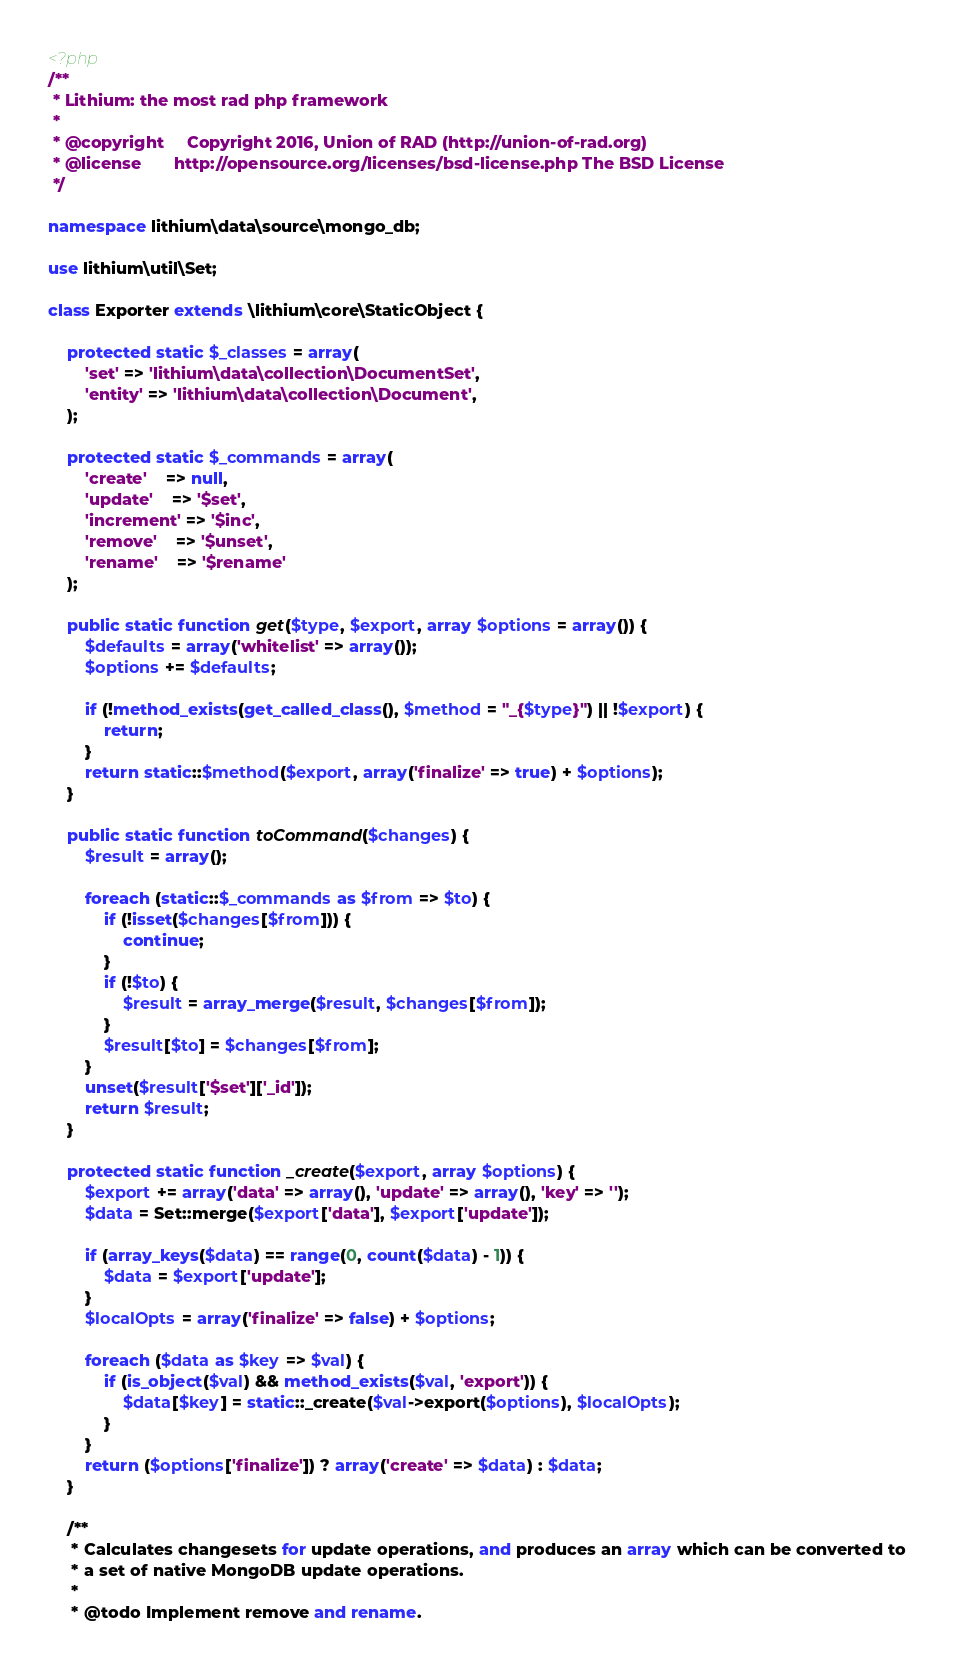Convert code to text. <code><loc_0><loc_0><loc_500><loc_500><_PHP_><?php
/**
 * Lithium: the most rad php framework
 *
 * @copyright     Copyright 2016, Union of RAD (http://union-of-rad.org)
 * @license       http://opensource.org/licenses/bsd-license.php The BSD License
 */

namespace lithium\data\source\mongo_db;

use lithium\util\Set;

class Exporter extends \lithium\core\StaticObject {

	protected static $_classes = array(
		'set' => 'lithium\data\collection\DocumentSet',
		'entity' => 'lithium\data\collection\Document',
	);

	protected static $_commands = array(
		'create'    => null,
		'update'    => '$set',
		'increment' => '$inc',
		'remove'    => '$unset',
		'rename'    => '$rename'
	);

	public static function get($type, $export, array $options = array()) {
		$defaults = array('whitelist' => array());
		$options += $defaults;

		if (!method_exists(get_called_class(), $method = "_{$type}") || !$export) {
			return;
		}
		return static::$method($export, array('finalize' => true) + $options);
	}

	public static function toCommand($changes) {
		$result = array();

		foreach (static::$_commands as $from => $to) {
			if (!isset($changes[$from])) {
				continue;
			}
			if (!$to) {
				$result = array_merge($result, $changes[$from]);
			}
			$result[$to] = $changes[$from];
		}
		unset($result['$set']['_id']);
		return $result;
	}

	protected static function _create($export, array $options) {
		$export += array('data' => array(), 'update' => array(), 'key' => '');
		$data = Set::merge($export['data'], $export['update']);

		if (array_keys($data) == range(0, count($data) - 1)) {
			$data = $export['update'];
		}
		$localOpts = array('finalize' => false) + $options;

		foreach ($data as $key => $val) {
			if (is_object($val) && method_exists($val, 'export')) {
				$data[$key] = static::_create($val->export($options), $localOpts);
			}
		}
		return ($options['finalize']) ? array('create' => $data) : $data;
	}

	/**
	 * Calculates changesets for update operations, and produces an array which can be converted to
	 * a set of native MongoDB update operations.
	 *
	 * @todo Implement remove and rename.</code> 